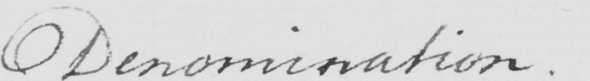What does this handwritten line say? Denomination . 